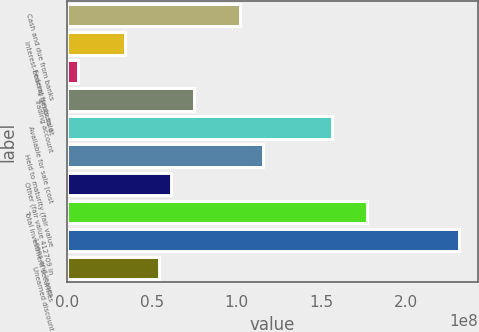Convert chart to OTSL. <chart><loc_0><loc_0><loc_500><loc_500><bar_chart><fcel>Cash and due from banks<fcel>Interest-bearing deposits at<fcel>Federal funds sold<fcel>Trading account<fcel>Available for sale (cost<fcel>Held to maturity (fair value<fcel>Other (fair value 412709 in<fcel>Total investment securities<fcel>Loans and leases<fcel>Unearned discount<nl><fcel>1.0203e+08<fcel>3.40127e+07<fcel>6.8059e+06<fcel>7.4823e+07<fcel>1.56443e+08<fcel>1.15633e+08<fcel>6.12196e+07<fcel>1.76849e+08<fcel>2.31262e+08<fcel>5.44178e+07<nl></chart> 